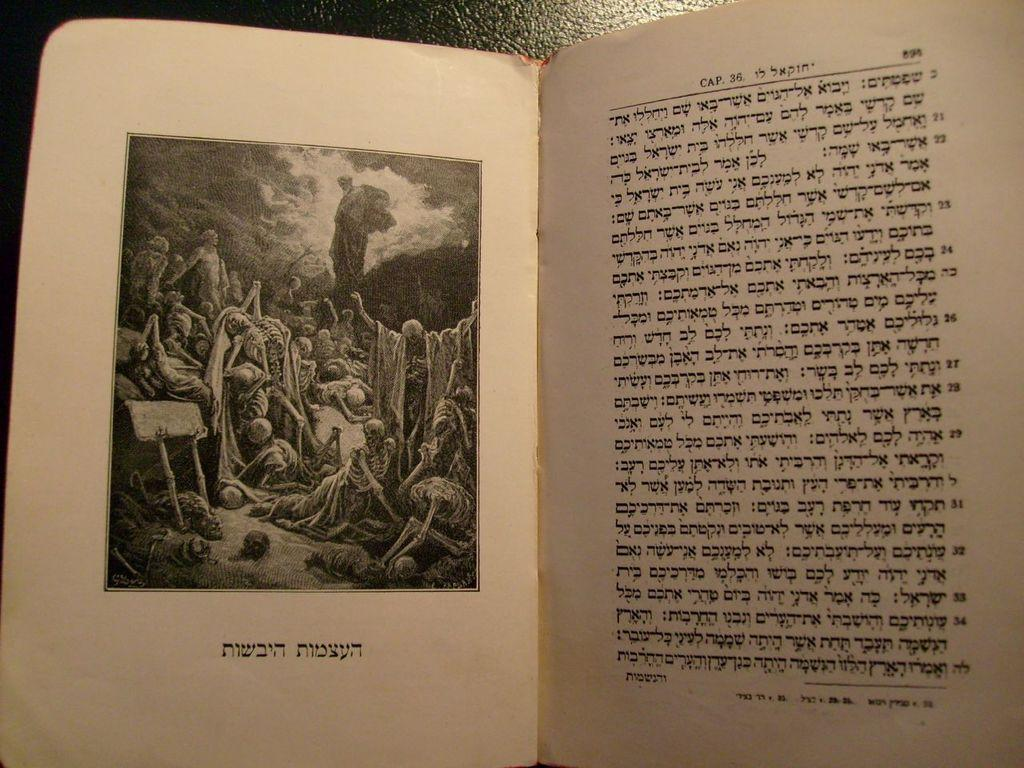<image>
Share a concise interpretation of the image provided. A book showing people suffering is opened to page 898. 